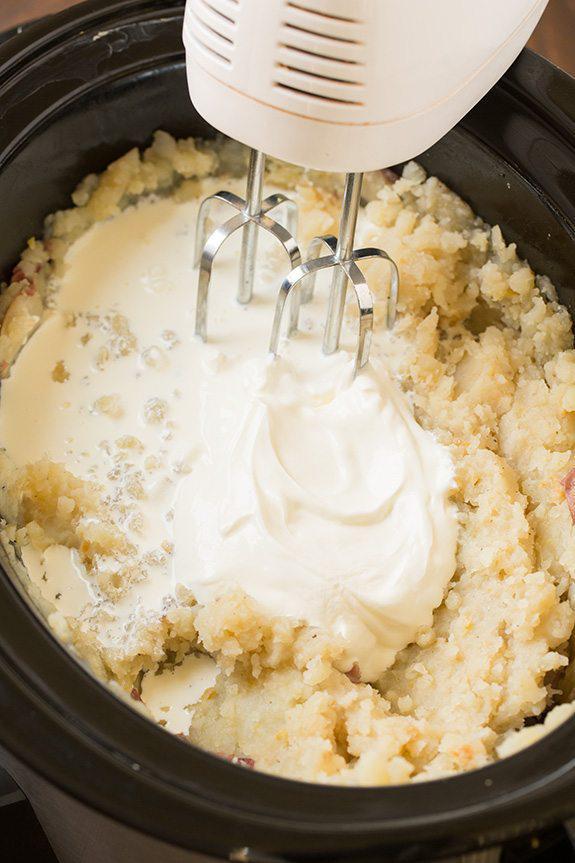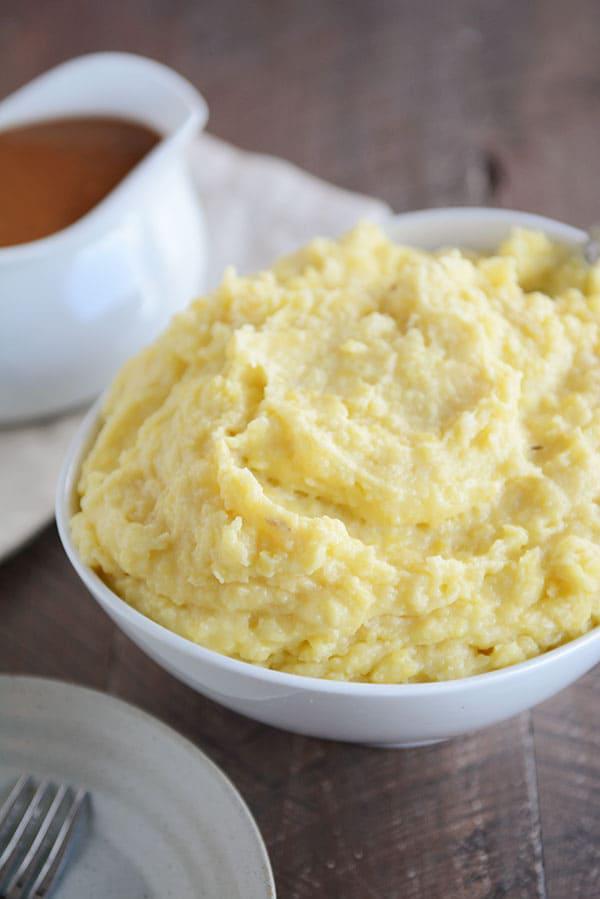The first image is the image on the left, the second image is the image on the right. Considering the images on both sides, is "An image includes ungarnished mashed potatoes in a round white bowl with a fork near it and a container of something behind it." valid? Answer yes or no. Yes. The first image is the image on the left, the second image is the image on the right. Evaluate the accuracy of this statement regarding the images: "The left and right image contains the same number of mash potatoes in a single white bowl.". Is it true? Answer yes or no. No. 